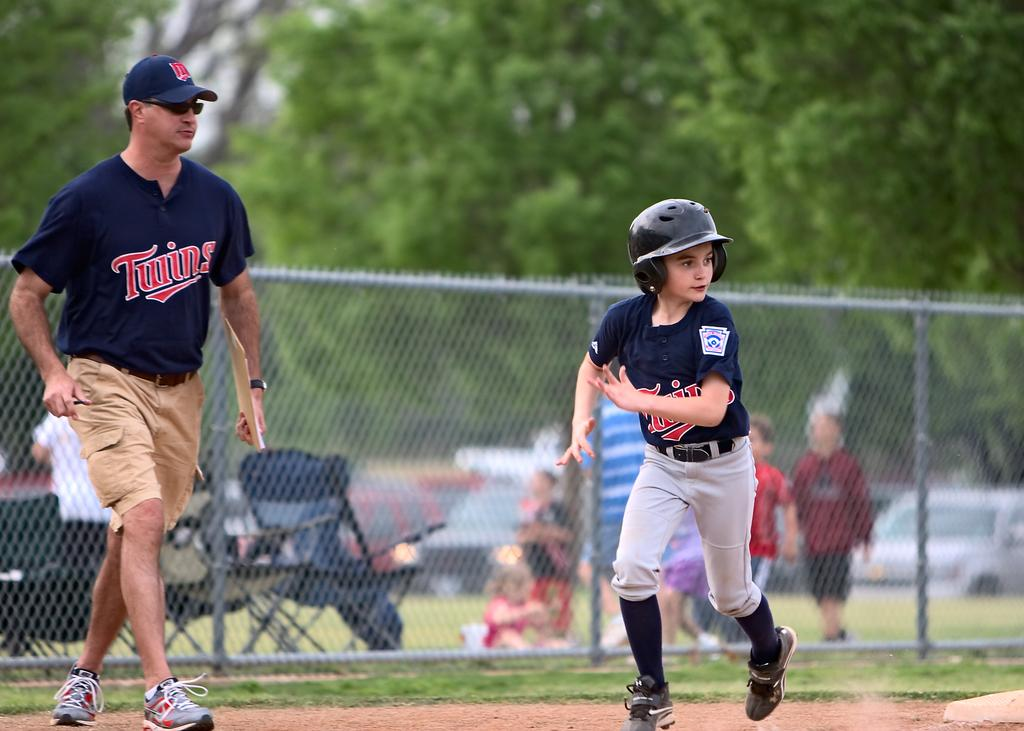<image>
Describe the image concisely. A boy baseball player is running in a baseball game with the coach is nearby, and both have Twins written on their shirts. 